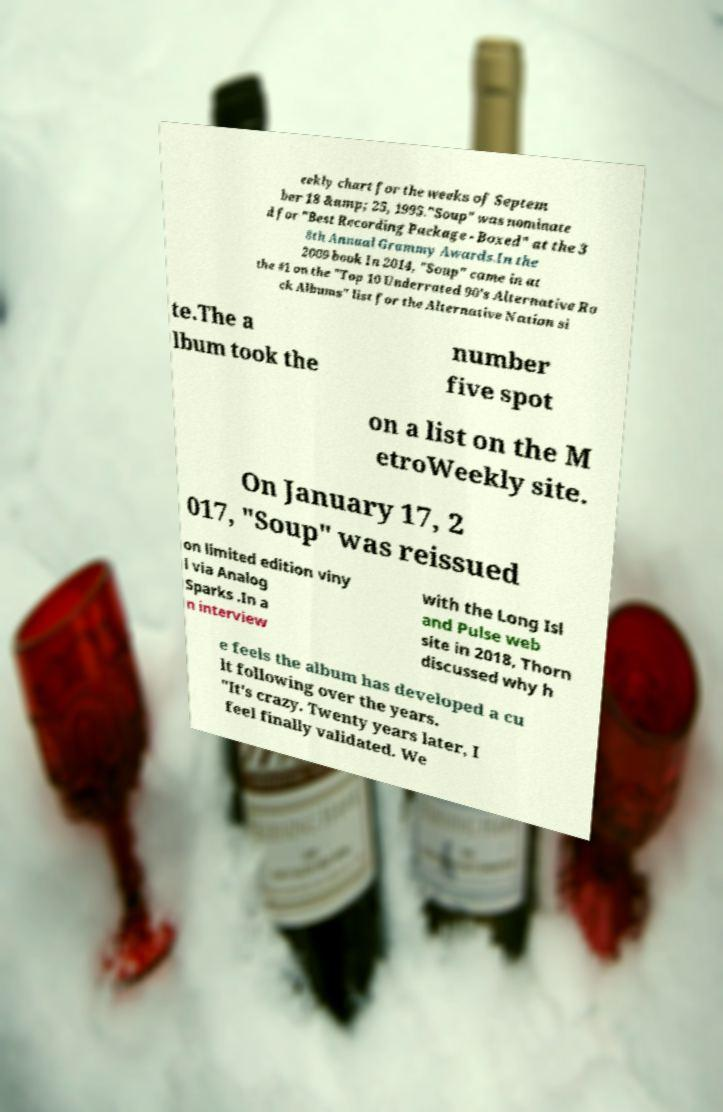Can you read and provide the text displayed in the image?This photo seems to have some interesting text. Can you extract and type it out for me? eekly chart for the weeks of Septem ber 18 &amp; 25, 1995."Soup" was nominate d for "Best Recording Package - Boxed" at the 3 8th Annual Grammy Awards.In the 2009 book In 2014, "Soup" came in at the #1 on the "Top 10 Underrated 90’s Alternative Ro ck Albums" list for the Alternative Nation si te.The a lbum took the number five spot on a list on the M etroWeekly site. On January 17, 2 017, "Soup" was reissued on limited edition viny l via Analog Sparks .In a n interview with the Long Isl and Pulse web site in 2018, Thorn discussed why h e feels the album has developed a cu lt following over the years. "It's crazy. Twenty years later, I feel finally validated. We 